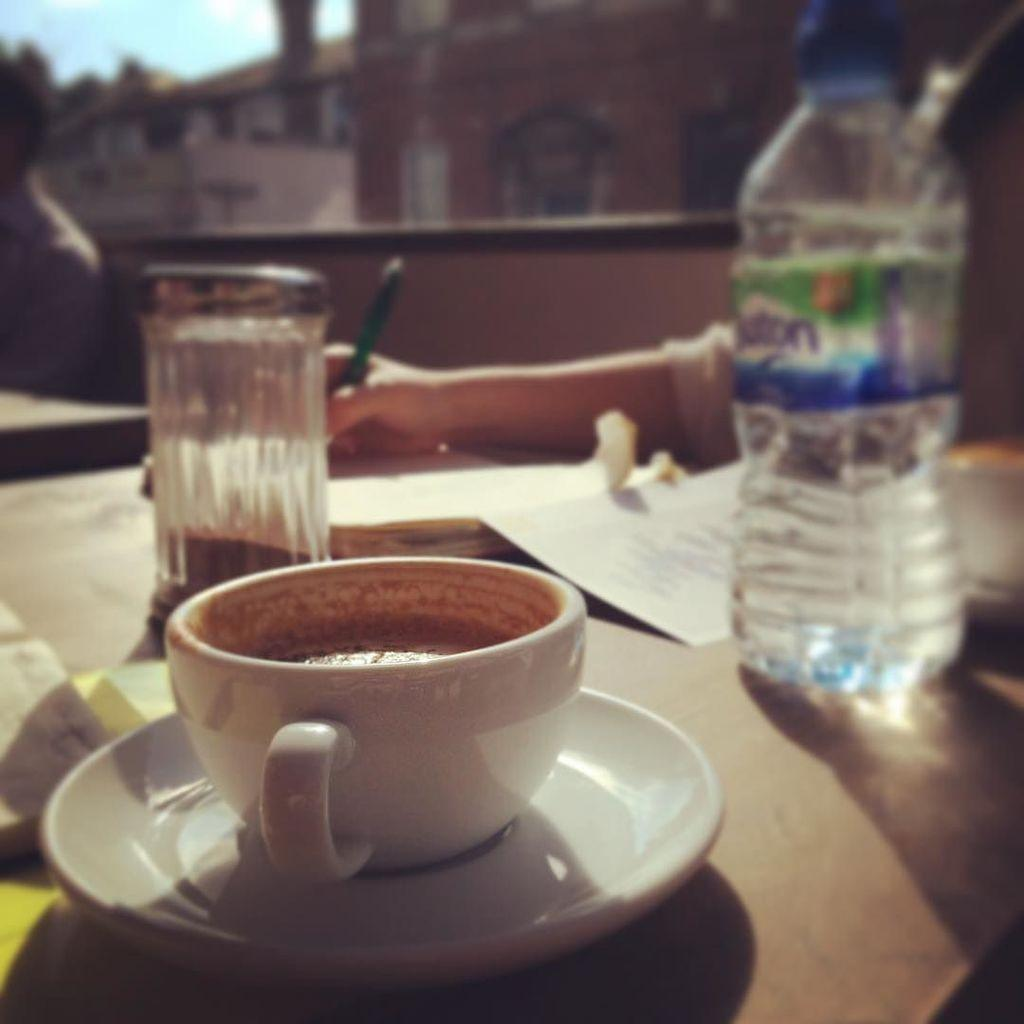What type of container is visible in the image? There is a cup in the image. What other objects can be seen in the image? There is a plate, a water bottle, and a paper in the image. Can you describe the person's hand in the background? In the background, a person's hand is holding a pen. Is there a stranger wearing a crown in the image? No, there is no stranger or crown present in the image. 